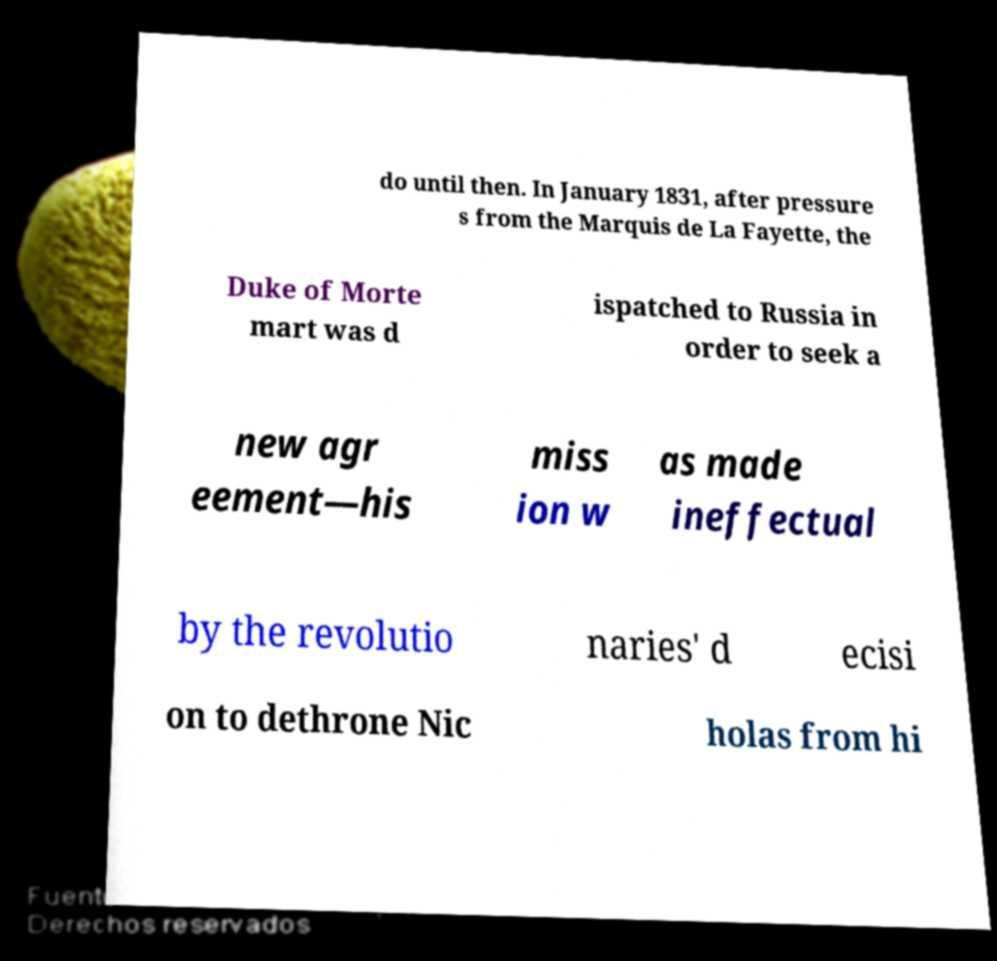Can you read and provide the text displayed in the image?This photo seems to have some interesting text. Can you extract and type it out for me? do until then. In January 1831, after pressure s from the Marquis de La Fayette, the Duke of Morte mart was d ispatched to Russia in order to seek a new agr eement—his miss ion w as made ineffectual by the revolutio naries' d ecisi on to dethrone Nic holas from hi 